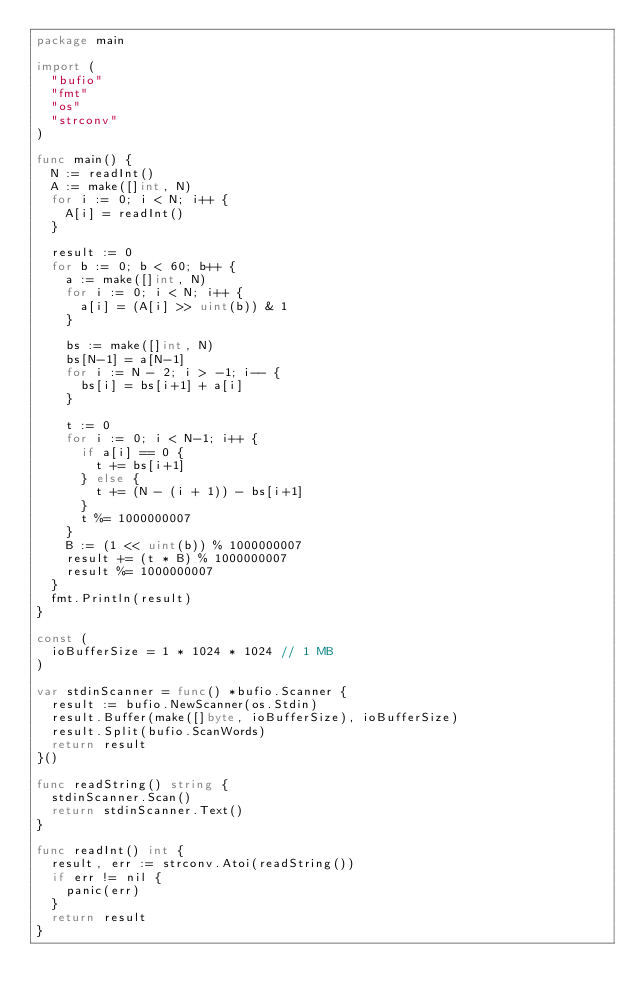<code> <loc_0><loc_0><loc_500><loc_500><_Go_>package main

import (
	"bufio"
	"fmt"
	"os"
	"strconv"
)

func main() {
	N := readInt()
	A := make([]int, N)
	for i := 0; i < N; i++ {
		A[i] = readInt()
	}

	result := 0
	for b := 0; b < 60; b++ {
		a := make([]int, N)
		for i := 0; i < N; i++ {
			a[i] = (A[i] >> uint(b)) & 1
		}

		bs := make([]int, N)
		bs[N-1] = a[N-1]
		for i := N - 2; i > -1; i-- {
			bs[i] = bs[i+1] + a[i]
		}

		t := 0
		for i := 0; i < N-1; i++ {
			if a[i] == 0 {
				t += bs[i+1]
			} else {
				t += (N - (i + 1)) - bs[i+1]
			}
			t %= 1000000007
		}
		B := (1 << uint(b)) % 1000000007
		result += (t * B) % 1000000007
		result %= 1000000007
	}
	fmt.Println(result)
}

const (
	ioBufferSize = 1 * 1024 * 1024 // 1 MB
)

var stdinScanner = func() *bufio.Scanner {
	result := bufio.NewScanner(os.Stdin)
	result.Buffer(make([]byte, ioBufferSize), ioBufferSize)
	result.Split(bufio.ScanWords)
	return result
}()

func readString() string {
	stdinScanner.Scan()
	return stdinScanner.Text()
}

func readInt() int {
	result, err := strconv.Atoi(readString())
	if err != nil {
		panic(err)
	}
	return result
}
</code> 